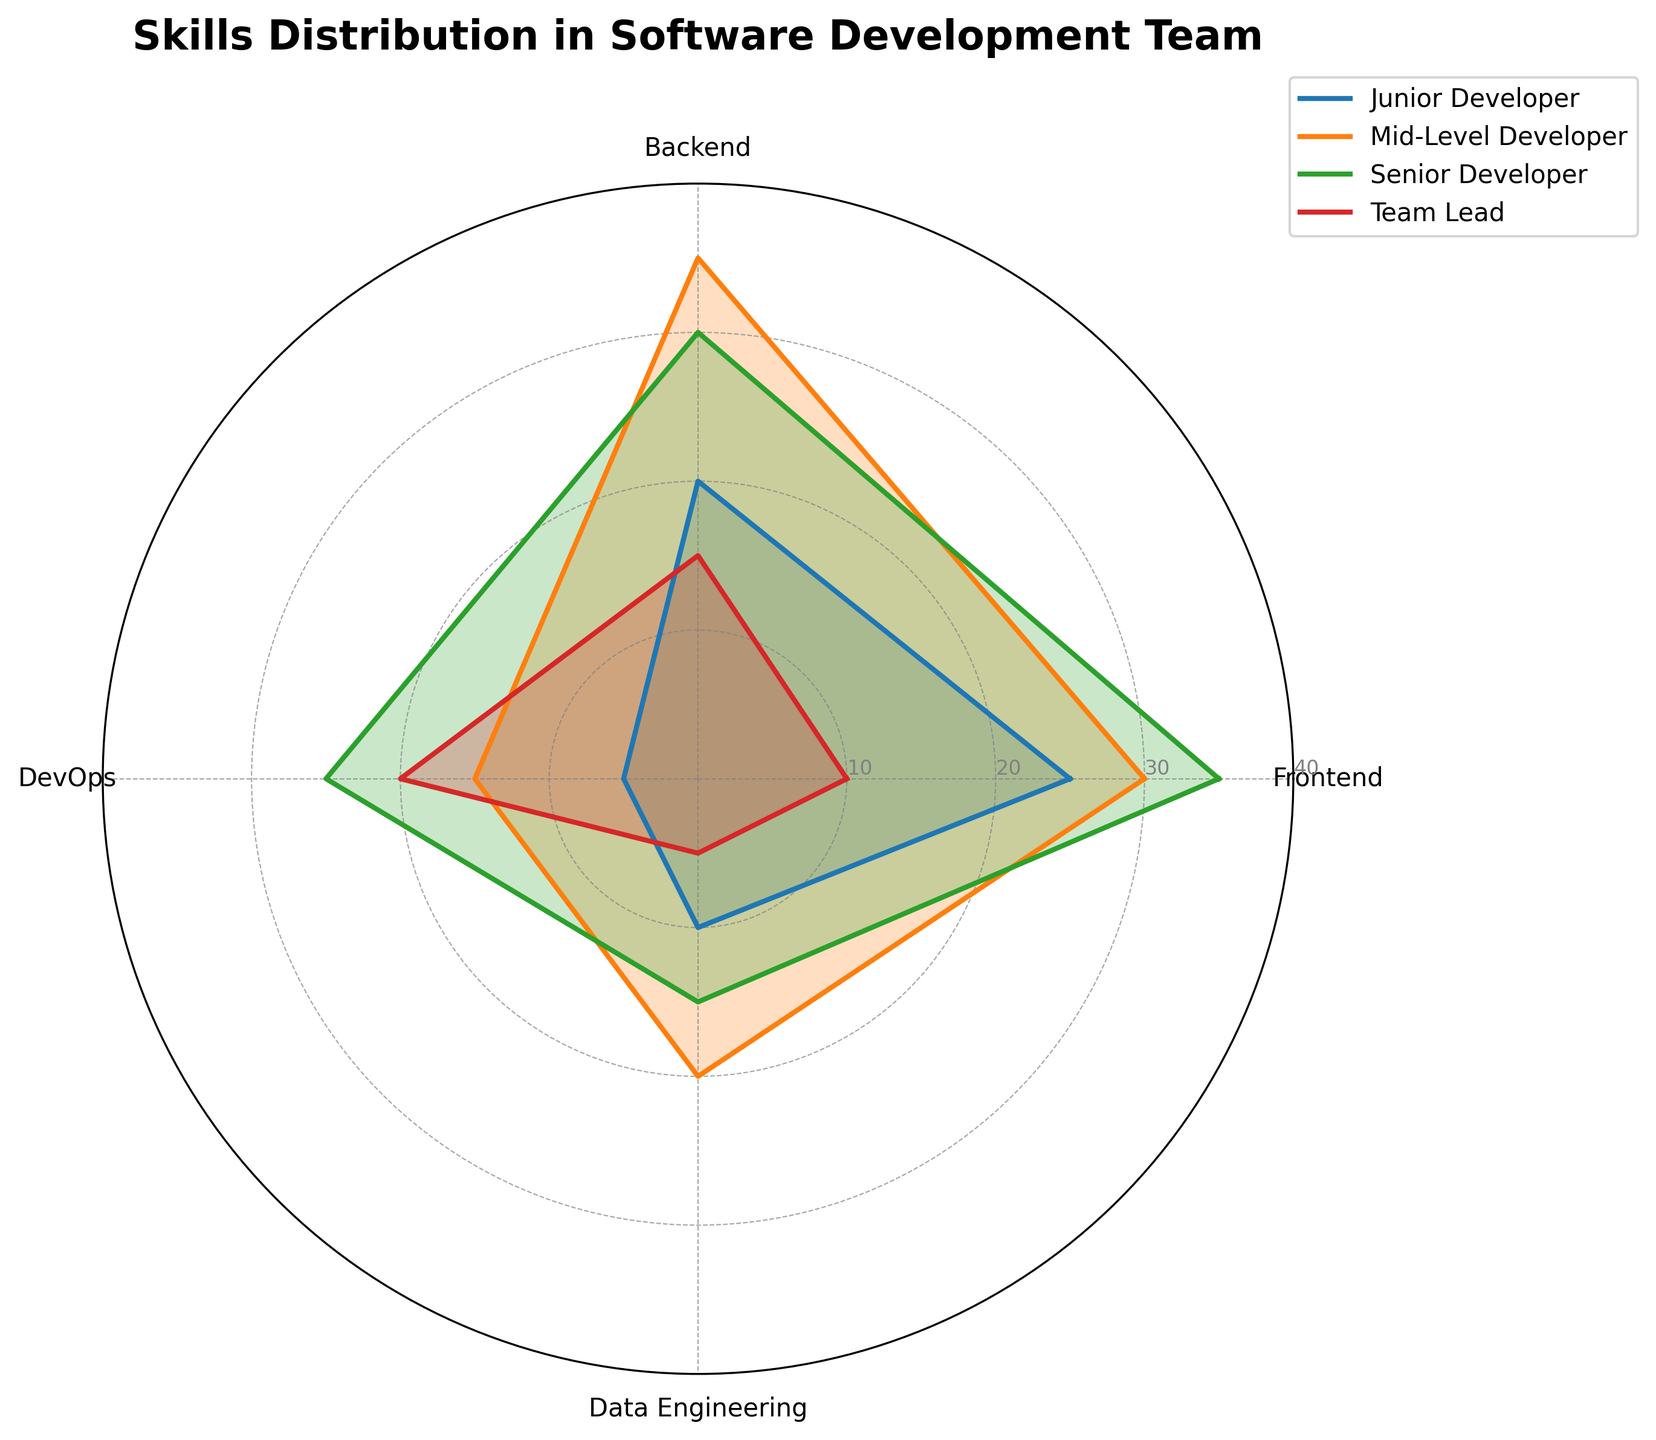Which expertise area does the Mid-Level Developer have the highest score in? The figure shows the Mid-Level Developer's ratings across different expertise areas. By comparing the values, the highest score is in Backend development.
Answer: Backend Which developer has the highest score in DevOps? By examining the DevOps axis for each developer, the Senior Developer has the highest score with a value of 25.
Answer: Senior Developer What is the total score for the Team Lead across all expertise areas? Adding up the values for the Team Lead in each area: 10 (Frontend) + 15 (Backend) + 20 (DevOps) + 5 (Data Engineering) equals 50.
Answer: 50 How does the Senior Developer's DevOps score compare to the Junior Developer's Backend score? The Senior Developer's DevOps score is 25, while the Junior Developer's Backend score is 20. Thus, the Senior Developer's DevOps score is higher.
Answer: Senior Developer > Junior Developer Which expertise area has the highest overall scores summed across all developers? Summing the scores for each expertise area:
- Frontend: 25 + 30 + 35 + 10 = 100
- Backend: 20 + 35 + 30 + 15 = 100
- DevOps: 5 + 15 + 25 + 20 = 65
- Data Engineering: 10 + 20 + 15 + 5 = 50 
Frontend and Backend both have the highest total scores of 100.
Answer: Frontend, Backend What is the difference between the highest and lowest scores for the Junior Developer? For the Junior Developer: 
- Highest: Frontend (25)
- Lowest: DevOps (5)
The difference is 25 - 5 = 20.
Answer: 20 Who has the lowest score in Data Engineering? The figure shows that the Team Lead has the lowest score in Data Engineering with a value of 5.
Answer: Team Lead How much higher is the Senior Developer's Backend score compared to the Junior Developer's Backend score? The Senior Developer’s Backend score is 30, and the Junior Developer’s Backend score is 20. The difference is 30 - 20 = 10.
Answer: 10 